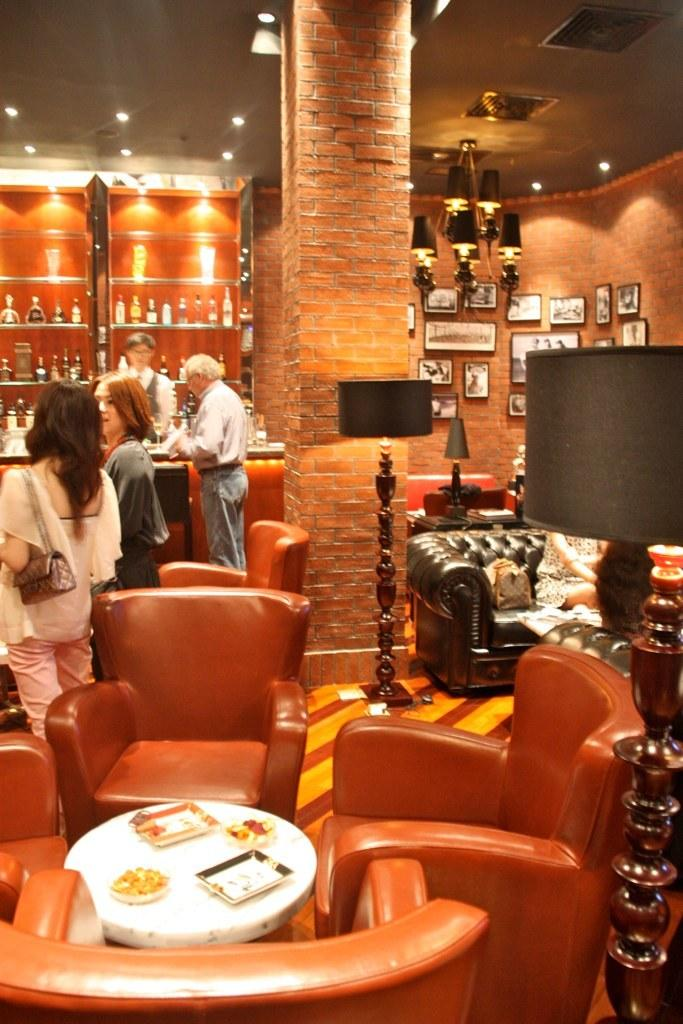What can be seen in the image involving people? There are people standing in the image. What furniture is present in the image? There are chairs around a table in the image. What is the source of light on the table? There is a table lamp in the image. What is the material and color of the pillar in the image? The pillar in the image is made up of red bricks. What is the material and color of the wall in the image? The wall in the image is made up of red bricks. How many friends are sitting on the chairs in the image? There is no mention of friends in the image; it only shows people standing. What type of connection can be seen between the people in the image? There is no indication of a connection between the people in the image, as they are simply standing. 